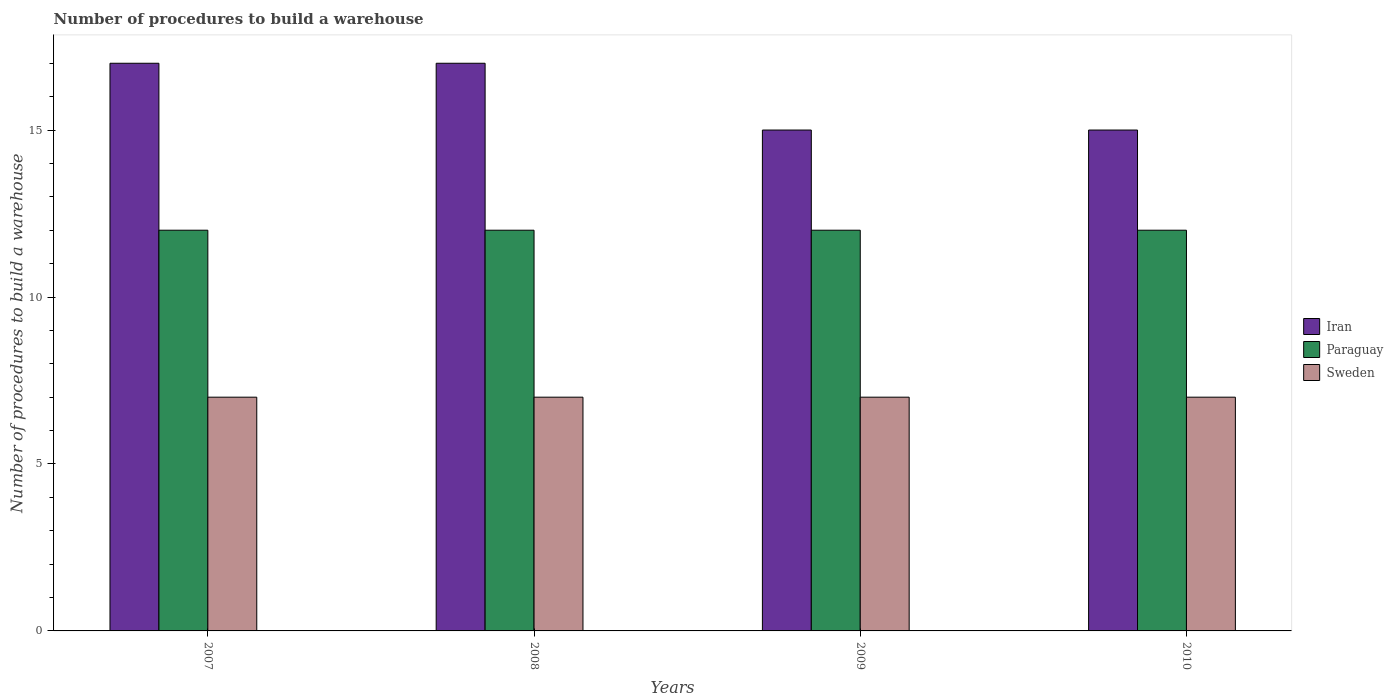How many bars are there on the 1st tick from the left?
Give a very brief answer. 3. What is the number of procedures to build a warehouse in in Sweden in 2008?
Your answer should be very brief. 7. Across all years, what is the maximum number of procedures to build a warehouse in in Sweden?
Ensure brevity in your answer.  7. Across all years, what is the minimum number of procedures to build a warehouse in in Iran?
Ensure brevity in your answer.  15. In which year was the number of procedures to build a warehouse in in Iran maximum?
Provide a short and direct response. 2007. In which year was the number of procedures to build a warehouse in in Iran minimum?
Your response must be concise. 2009. What is the total number of procedures to build a warehouse in in Paraguay in the graph?
Keep it short and to the point. 48. What is the difference between the number of procedures to build a warehouse in in Paraguay in 2007 and the number of procedures to build a warehouse in in Iran in 2009?
Provide a short and direct response. -3. In the year 2009, what is the difference between the number of procedures to build a warehouse in in Iran and number of procedures to build a warehouse in in Sweden?
Make the answer very short. 8. In how many years, is the number of procedures to build a warehouse in in Paraguay greater than 1?
Ensure brevity in your answer.  4. What is the ratio of the number of procedures to build a warehouse in in Paraguay in 2007 to that in 2010?
Your response must be concise. 1. Is the number of procedures to build a warehouse in in Paraguay in 2007 less than that in 2008?
Keep it short and to the point. No. Is the difference between the number of procedures to build a warehouse in in Iran in 2007 and 2008 greater than the difference between the number of procedures to build a warehouse in in Sweden in 2007 and 2008?
Provide a succinct answer. No. What does the 1st bar from the left in 2008 represents?
Offer a very short reply. Iran. What does the 2nd bar from the right in 2008 represents?
Your answer should be very brief. Paraguay. Does the graph contain grids?
Make the answer very short. No. Where does the legend appear in the graph?
Your response must be concise. Center right. How are the legend labels stacked?
Give a very brief answer. Vertical. What is the title of the graph?
Ensure brevity in your answer.  Number of procedures to build a warehouse. Does "Swaziland" appear as one of the legend labels in the graph?
Provide a succinct answer. No. What is the label or title of the Y-axis?
Make the answer very short. Number of procedures to build a warehouse. What is the Number of procedures to build a warehouse of Iran in 2007?
Ensure brevity in your answer.  17. What is the Number of procedures to build a warehouse in Paraguay in 2007?
Offer a terse response. 12. What is the Number of procedures to build a warehouse in Iran in 2010?
Provide a succinct answer. 15. What is the Number of procedures to build a warehouse in Paraguay in 2010?
Provide a short and direct response. 12. What is the Number of procedures to build a warehouse of Sweden in 2010?
Your response must be concise. 7. Across all years, what is the maximum Number of procedures to build a warehouse of Iran?
Give a very brief answer. 17. Across all years, what is the maximum Number of procedures to build a warehouse of Sweden?
Your answer should be compact. 7. Across all years, what is the minimum Number of procedures to build a warehouse of Sweden?
Offer a very short reply. 7. What is the total Number of procedures to build a warehouse of Iran in the graph?
Provide a succinct answer. 64. What is the total Number of procedures to build a warehouse of Paraguay in the graph?
Provide a succinct answer. 48. What is the total Number of procedures to build a warehouse of Sweden in the graph?
Ensure brevity in your answer.  28. What is the difference between the Number of procedures to build a warehouse in Iran in 2007 and that in 2008?
Ensure brevity in your answer.  0. What is the difference between the Number of procedures to build a warehouse of Paraguay in 2007 and that in 2008?
Offer a terse response. 0. What is the difference between the Number of procedures to build a warehouse in Sweden in 2007 and that in 2009?
Ensure brevity in your answer.  0. What is the difference between the Number of procedures to build a warehouse of Paraguay in 2008 and that in 2009?
Your answer should be compact. 0. What is the difference between the Number of procedures to build a warehouse of Sweden in 2008 and that in 2009?
Provide a succinct answer. 0. What is the difference between the Number of procedures to build a warehouse in Paraguay in 2008 and that in 2010?
Provide a short and direct response. 0. What is the difference between the Number of procedures to build a warehouse of Sweden in 2008 and that in 2010?
Provide a succinct answer. 0. What is the difference between the Number of procedures to build a warehouse of Iran in 2007 and the Number of procedures to build a warehouse of Paraguay in 2008?
Provide a short and direct response. 5. What is the difference between the Number of procedures to build a warehouse in Paraguay in 2007 and the Number of procedures to build a warehouse in Sweden in 2008?
Offer a very short reply. 5. What is the difference between the Number of procedures to build a warehouse in Paraguay in 2007 and the Number of procedures to build a warehouse in Sweden in 2009?
Your answer should be compact. 5. What is the difference between the Number of procedures to build a warehouse of Paraguay in 2007 and the Number of procedures to build a warehouse of Sweden in 2010?
Offer a very short reply. 5. What is the difference between the Number of procedures to build a warehouse in Iran in 2008 and the Number of procedures to build a warehouse in Sweden in 2009?
Your answer should be compact. 10. What is the difference between the Number of procedures to build a warehouse of Iran in 2008 and the Number of procedures to build a warehouse of Sweden in 2010?
Offer a very short reply. 10. What is the difference between the Number of procedures to build a warehouse of Iran in 2009 and the Number of procedures to build a warehouse of Paraguay in 2010?
Offer a very short reply. 3. What is the difference between the Number of procedures to build a warehouse in Iran in 2009 and the Number of procedures to build a warehouse in Sweden in 2010?
Make the answer very short. 8. What is the difference between the Number of procedures to build a warehouse in Paraguay in 2009 and the Number of procedures to build a warehouse in Sweden in 2010?
Offer a terse response. 5. In the year 2007, what is the difference between the Number of procedures to build a warehouse of Iran and Number of procedures to build a warehouse of Paraguay?
Offer a terse response. 5. In the year 2008, what is the difference between the Number of procedures to build a warehouse of Iran and Number of procedures to build a warehouse of Sweden?
Provide a short and direct response. 10. In the year 2008, what is the difference between the Number of procedures to build a warehouse in Paraguay and Number of procedures to build a warehouse in Sweden?
Your response must be concise. 5. In the year 2009, what is the difference between the Number of procedures to build a warehouse in Paraguay and Number of procedures to build a warehouse in Sweden?
Provide a succinct answer. 5. In the year 2010, what is the difference between the Number of procedures to build a warehouse in Iran and Number of procedures to build a warehouse in Paraguay?
Offer a very short reply. 3. In the year 2010, what is the difference between the Number of procedures to build a warehouse of Paraguay and Number of procedures to build a warehouse of Sweden?
Ensure brevity in your answer.  5. What is the ratio of the Number of procedures to build a warehouse in Iran in 2007 to that in 2008?
Give a very brief answer. 1. What is the ratio of the Number of procedures to build a warehouse of Paraguay in 2007 to that in 2008?
Give a very brief answer. 1. What is the ratio of the Number of procedures to build a warehouse in Iran in 2007 to that in 2009?
Provide a succinct answer. 1.13. What is the ratio of the Number of procedures to build a warehouse of Paraguay in 2007 to that in 2009?
Provide a succinct answer. 1. What is the ratio of the Number of procedures to build a warehouse in Sweden in 2007 to that in 2009?
Ensure brevity in your answer.  1. What is the ratio of the Number of procedures to build a warehouse in Iran in 2007 to that in 2010?
Offer a terse response. 1.13. What is the ratio of the Number of procedures to build a warehouse in Sweden in 2007 to that in 2010?
Provide a short and direct response. 1. What is the ratio of the Number of procedures to build a warehouse of Iran in 2008 to that in 2009?
Provide a succinct answer. 1.13. What is the ratio of the Number of procedures to build a warehouse in Paraguay in 2008 to that in 2009?
Keep it short and to the point. 1. What is the ratio of the Number of procedures to build a warehouse of Sweden in 2008 to that in 2009?
Offer a terse response. 1. What is the ratio of the Number of procedures to build a warehouse in Iran in 2008 to that in 2010?
Your answer should be compact. 1.13. What is the ratio of the Number of procedures to build a warehouse in Paraguay in 2008 to that in 2010?
Offer a terse response. 1. What is the ratio of the Number of procedures to build a warehouse of Paraguay in 2009 to that in 2010?
Your answer should be compact. 1. What is the ratio of the Number of procedures to build a warehouse in Sweden in 2009 to that in 2010?
Make the answer very short. 1. What is the difference between the highest and the second highest Number of procedures to build a warehouse of Iran?
Your answer should be compact. 0. What is the difference between the highest and the lowest Number of procedures to build a warehouse in Paraguay?
Provide a short and direct response. 0. 